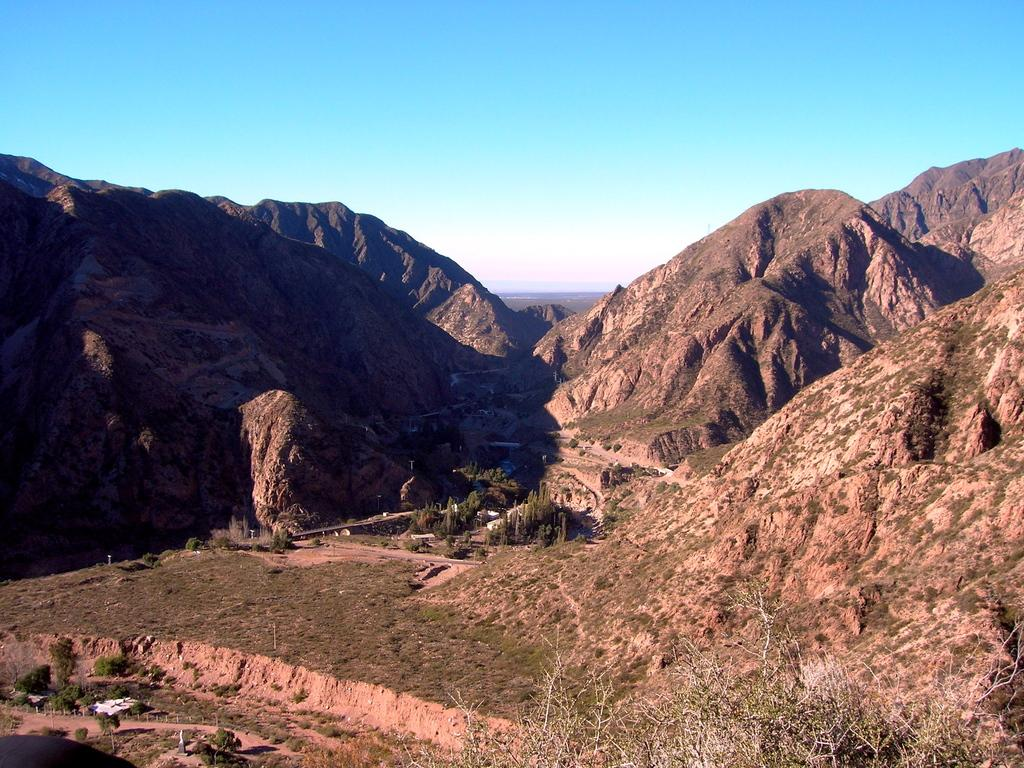What type of geographical feature is the main subject of the image? There is a valley in the image. What natural barriers surround the valley? Huge mountains surround the valley. What can be seen in the background of the image? The sky is visible in the background of the image. How many cubs can be seen playing in the valley in the image? There are no cubs present in the image; it features a valley surrounded by mountains. What type of ant is visible crawling on the mountain in the image? There are no ants visible in the image; it only shows a valley surrounded by mountains and a visible sky. 